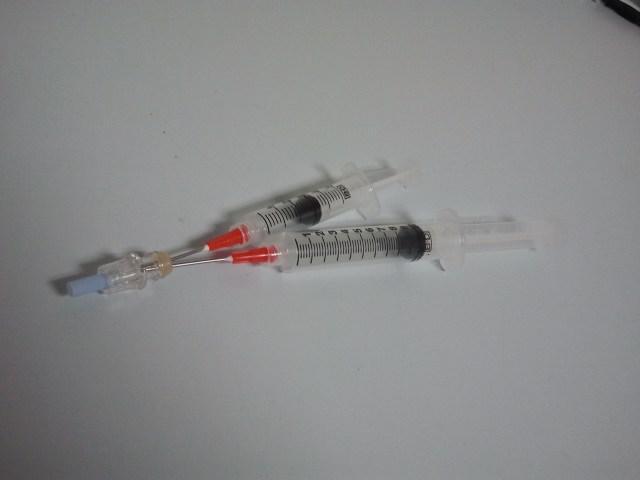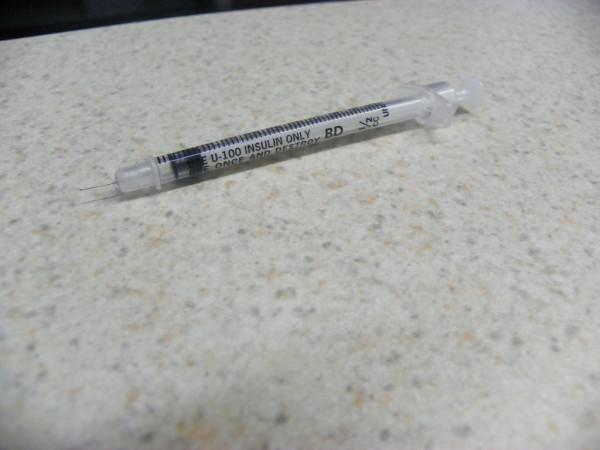The first image is the image on the left, the second image is the image on the right. Given the left and right images, does the statement "There are two syringes lying on the floor" hold true? Answer yes or no. No. The first image is the image on the left, the second image is the image on the right. Assess this claim about the two images: "Each image shows one syringe, which is on a cement-type surface.". Correct or not? Answer yes or no. No. 